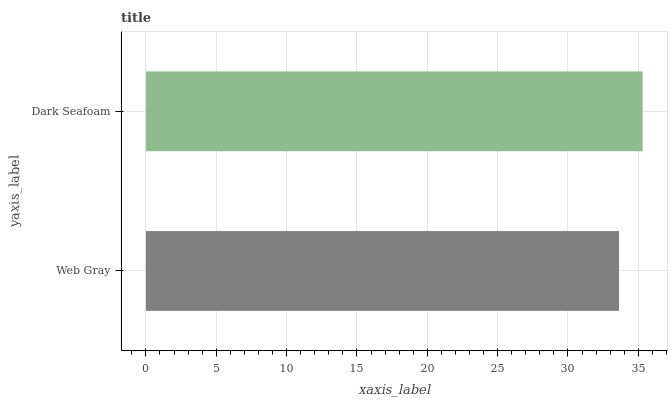Is Web Gray the minimum?
Answer yes or no. Yes. Is Dark Seafoam the maximum?
Answer yes or no. Yes. Is Dark Seafoam the minimum?
Answer yes or no. No. Is Dark Seafoam greater than Web Gray?
Answer yes or no. Yes. Is Web Gray less than Dark Seafoam?
Answer yes or no. Yes. Is Web Gray greater than Dark Seafoam?
Answer yes or no. No. Is Dark Seafoam less than Web Gray?
Answer yes or no. No. Is Dark Seafoam the high median?
Answer yes or no. Yes. Is Web Gray the low median?
Answer yes or no. Yes. Is Web Gray the high median?
Answer yes or no. No. Is Dark Seafoam the low median?
Answer yes or no. No. 